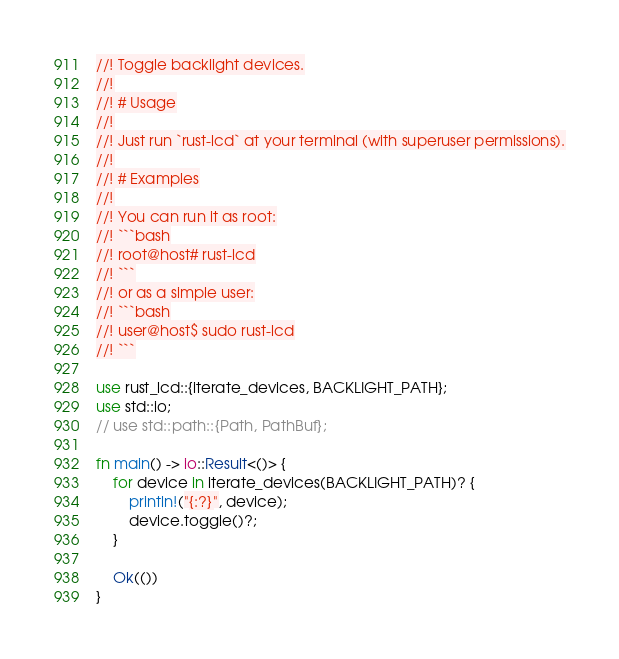Convert code to text. <code><loc_0><loc_0><loc_500><loc_500><_Rust_>//! Toggle backlight devices.
//!
//! # Usage
//!
//! Just run `rust-lcd` at your terminal (with superuser permissions).
//!
//! # Examples
//!
//! You can run it as root:
//! ```bash
//! root@host# rust-lcd
//! ```
//! or as a simple user:
//! ```bash
//! user@host$ sudo rust-lcd
//! ```

use rust_lcd::{iterate_devices, BACKLIGHT_PATH};
use std::io;
// use std::path::{Path, PathBuf};

fn main() -> io::Result<()> {
    for device in iterate_devices(BACKLIGHT_PATH)? {
        println!("{:?}", device);
        device.toggle()?;
    }

    Ok(())
}
</code> 